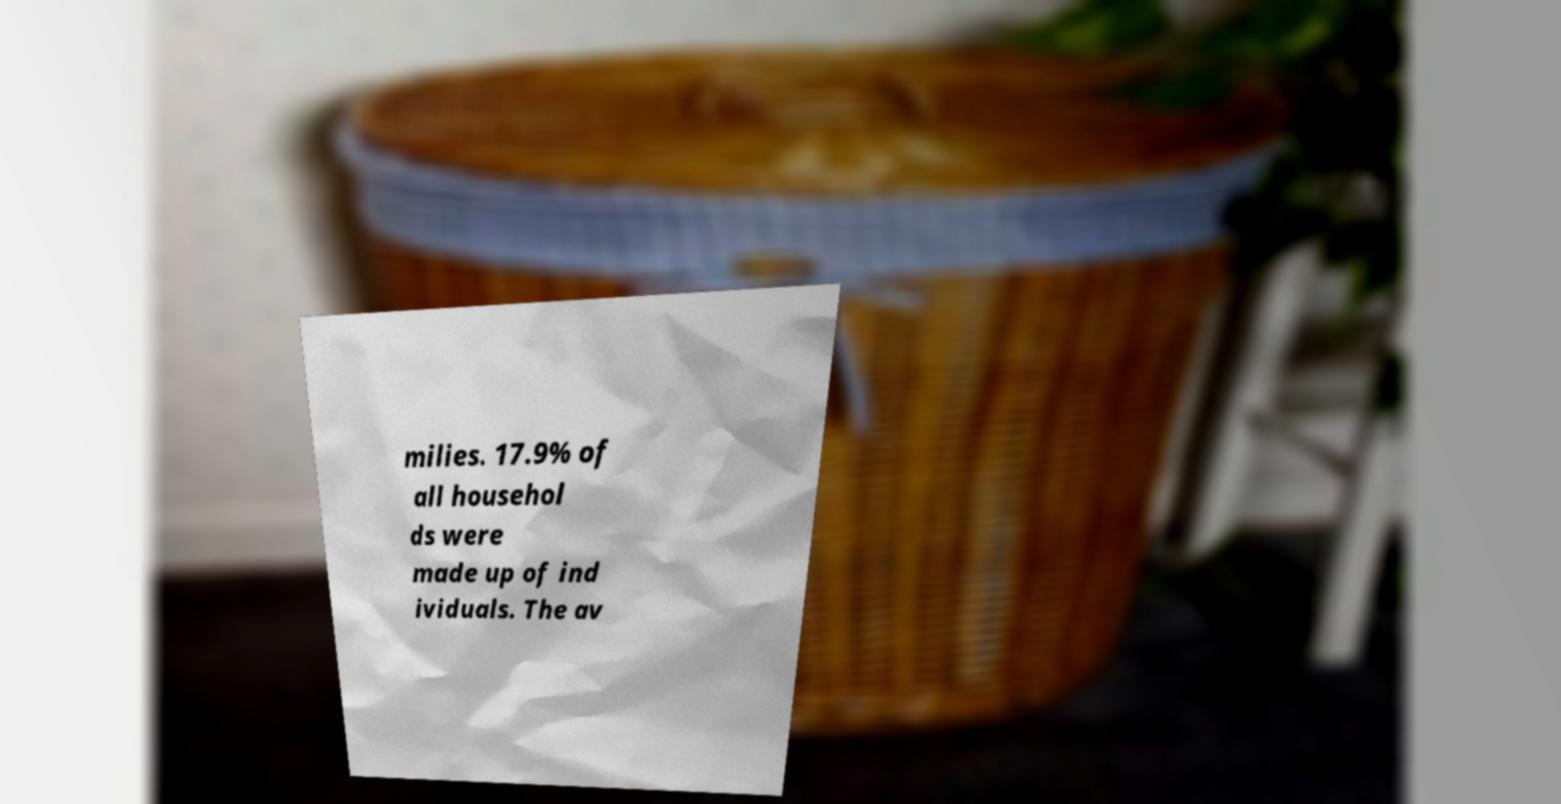Could you extract and type out the text from this image? milies. 17.9% of all househol ds were made up of ind ividuals. The av 